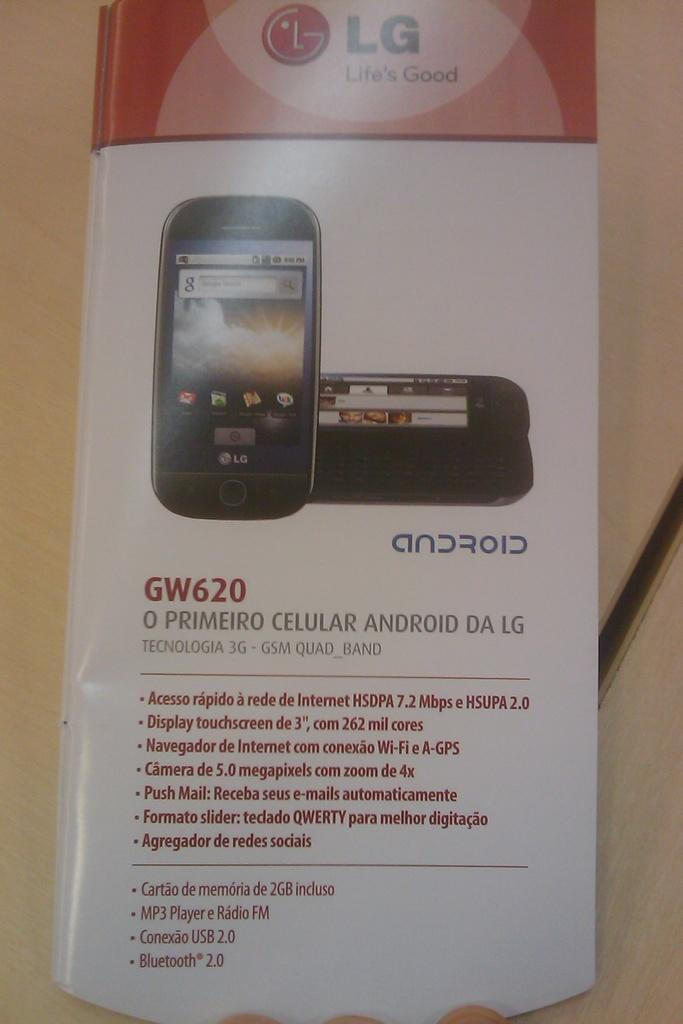<image>
Present a compact description of the photo's key features. A paper with LG, Life's Good GW620 android phone details. 